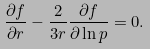Convert formula to latex. <formula><loc_0><loc_0><loc_500><loc_500>\frac { \partial f } { \partial r } - \frac { 2 } { 3 r } \frac { \partial f } { \partial \ln p } = 0 .</formula> 